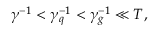<formula> <loc_0><loc_0><loc_500><loc_500>\gamma ^ { - 1 } < \gamma _ { q } ^ { - 1 } < \gamma _ { g } ^ { - 1 } \ll T ,</formula> 